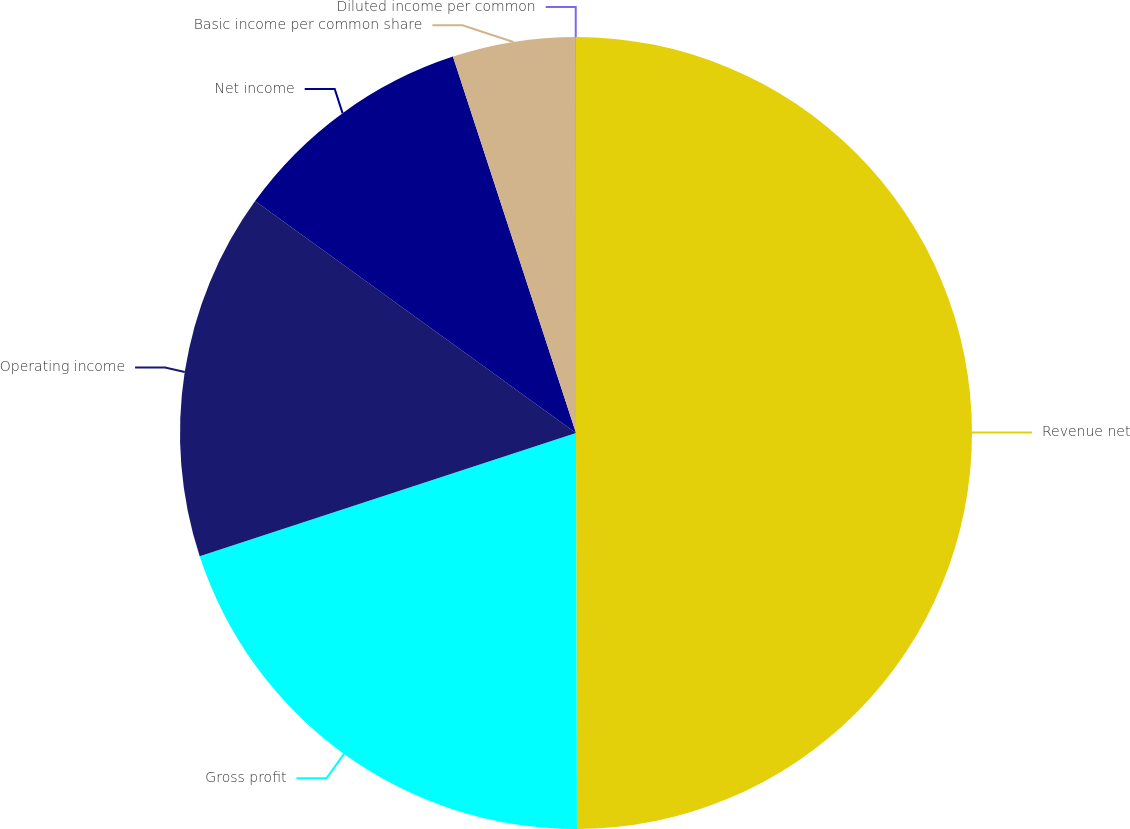<chart> <loc_0><loc_0><loc_500><loc_500><pie_chart><fcel>Revenue net<fcel>Gross profit<fcel>Operating income<fcel>Net income<fcel>Basic income per common share<fcel>Diluted income per common<nl><fcel>49.96%<fcel>20.0%<fcel>15.0%<fcel>10.01%<fcel>5.01%<fcel>0.02%<nl></chart> 